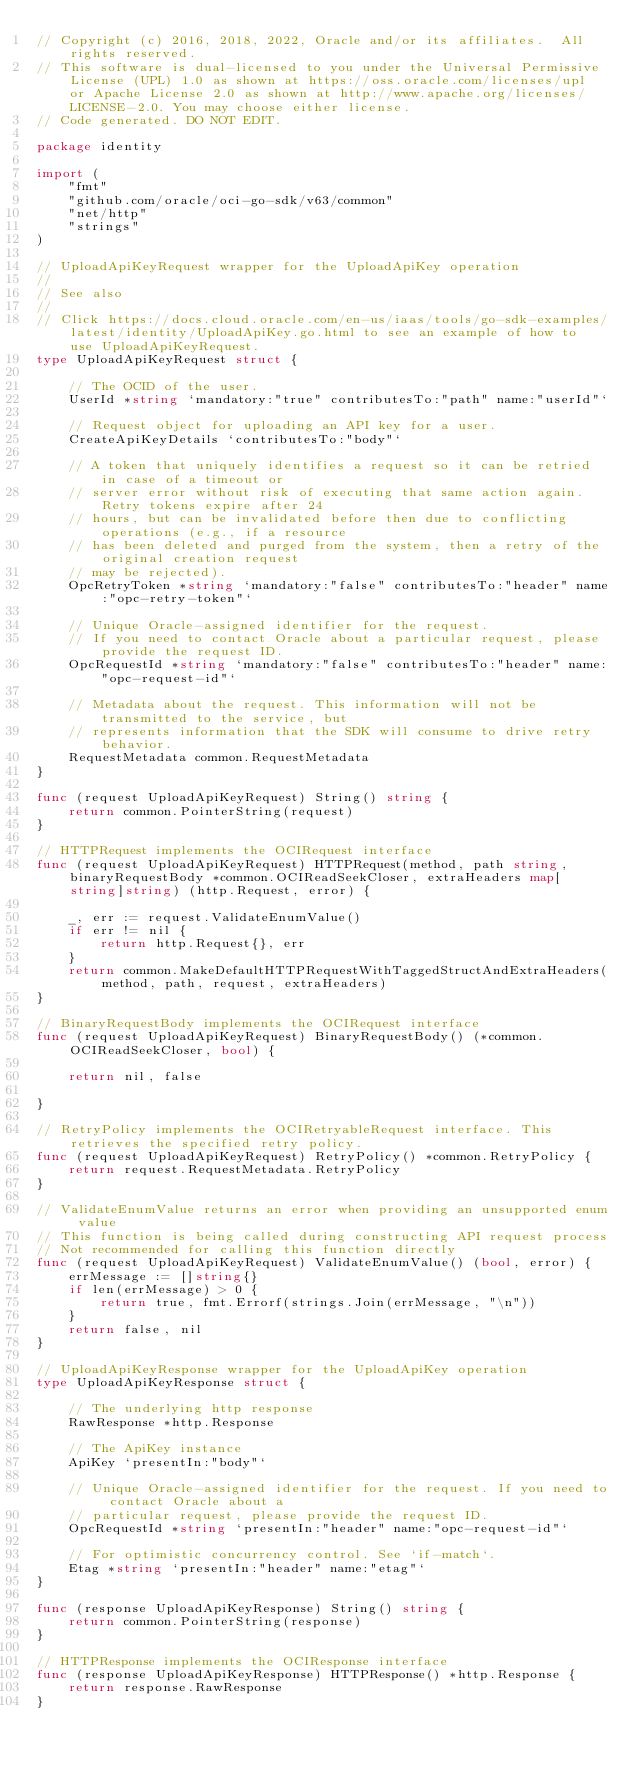<code> <loc_0><loc_0><loc_500><loc_500><_Go_>// Copyright (c) 2016, 2018, 2022, Oracle and/or its affiliates.  All rights reserved.
// This software is dual-licensed to you under the Universal Permissive License (UPL) 1.0 as shown at https://oss.oracle.com/licenses/upl or Apache License 2.0 as shown at http://www.apache.org/licenses/LICENSE-2.0. You may choose either license.
// Code generated. DO NOT EDIT.

package identity

import (
	"fmt"
	"github.com/oracle/oci-go-sdk/v63/common"
	"net/http"
	"strings"
)

// UploadApiKeyRequest wrapper for the UploadApiKey operation
//
// See also
//
// Click https://docs.cloud.oracle.com/en-us/iaas/tools/go-sdk-examples/latest/identity/UploadApiKey.go.html to see an example of how to use UploadApiKeyRequest.
type UploadApiKeyRequest struct {

	// The OCID of the user.
	UserId *string `mandatory:"true" contributesTo:"path" name:"userId"`

	// Request object for uploading an API key for a user.
	CreateApiKeyDetails `contributesTo:"body"`

	// A token that uniquely identifies a request so it can be retried in case of a timeout or
	// server error without risk of executing that same action again. Retry tokens expire after 24
	// hours, but can be invalidated before then due to conflicting operations (e.g., if a resource
	// has been deleted and purged from the system, then a retry of the original creation request
	// may be rejected).
	OpcRetryToken *string `mandatory:"false" contributesTo:"header" name:"opc-retry-token"`

	// Unique Oracle-assigned identifier for the request.
	// If you need to contact Oracle about a particular request, please provide the request ID.
	OpcRequestId *string `mandatory:"false" contributesTo:"header" name:"opc-request-id"`

	// Metadata about the request. This information will not be transmitted to the service, but
	// represents information that the SDK will consume to drive retry behavior.
	RequestMetadata common.RequestMetadata
}

func (request UploadApiKeyRequest) String() string {
	return common.PointerString(request)
}

// HTTPRequest implements the OCIRequest interface
func (request UploadApiKeyRequest) HTTPRequest(method, path string, binaryRequestBody *common.OCIReadSeekCloser, extraHeaders map[string]string) (http.Request, error) {

	_, err := request.ValidateEnumValue()
	if err != nil {
		return http.Request{}, err
	}
	return common.MakeDefaultHTTPRequestWithTaggedStructAndExtraHeaders(method, path, request, extraHeaders)
}

// BinaryRequestBody implements the OCIRequest interface
func (request UploadApiKeyRequest) BinaryRequestBody() (*common.OCIReadSeekCloser, bool) {

	return nil, false

}

// RetryPolicy implements the OCIRetryableRequest interface. This retrieves the specified retry policy.
func (request UploadApiKeyRequest) RetryPolicy() *common.RetryPolicy {
	return request.RequestMetadata.RetryPolicy
}

// ValidateEnumValue returns an error when providing an unsupported enum value
// This function is being called during constructing API request process
// Not recommended for calling this function directly
func (request UploadApiKeyRequest) ValidateEnumValue() (bool, error) {
	errMessage := []string{}
	if len(errMessage) > 0 {
		return true, fmt.Errorf(strings.Join(errMessage, "\n"))
	}
	return false, nil
}

// UploadApiKeyResponse wrapper for the UploadApiKey operation
type UploadApiKeyResponse struct {

	// The underlying http response
	RawResponse *http.Response

	// The ApiKey instance
	ApiKey `presentIn:"body"`

	// Unique Oracle-assigned identifier for the request. If you need to contact Oracle about a
	// particular request, please provide the request ID.
	OpcRequestId *string `presentIn:"header" name:"opc-request-id"`

	// For optimistic concurrency control. See `if-match`.
	Etag *string `presentIn:"header" name:"etag"`
}

func (response UploadApiKeyResponse) String() string {
	return common.PointerString(response)
}

// HTTPResponse implements the OCIResponse interface
func (response UploadApiKeyResponse) HTTPResponse() *http.Response {
	return response.RawResponse
}
</code> 